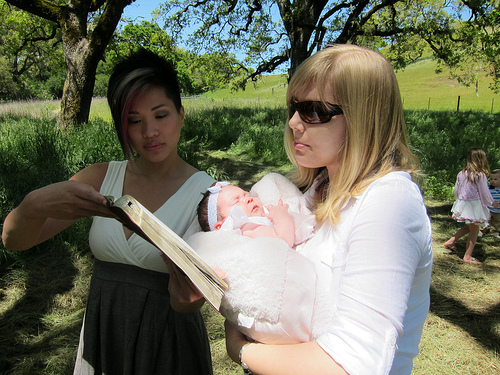<image>
Can you confirm if the book is in front of the baby? Yes. The book is positioned in front of the baby, appearing closer to the camera viewpoint. Is there a book in front of the woman? Yes. The book is positioned in front of the woman, appearing closer to the camera viewpoint. 